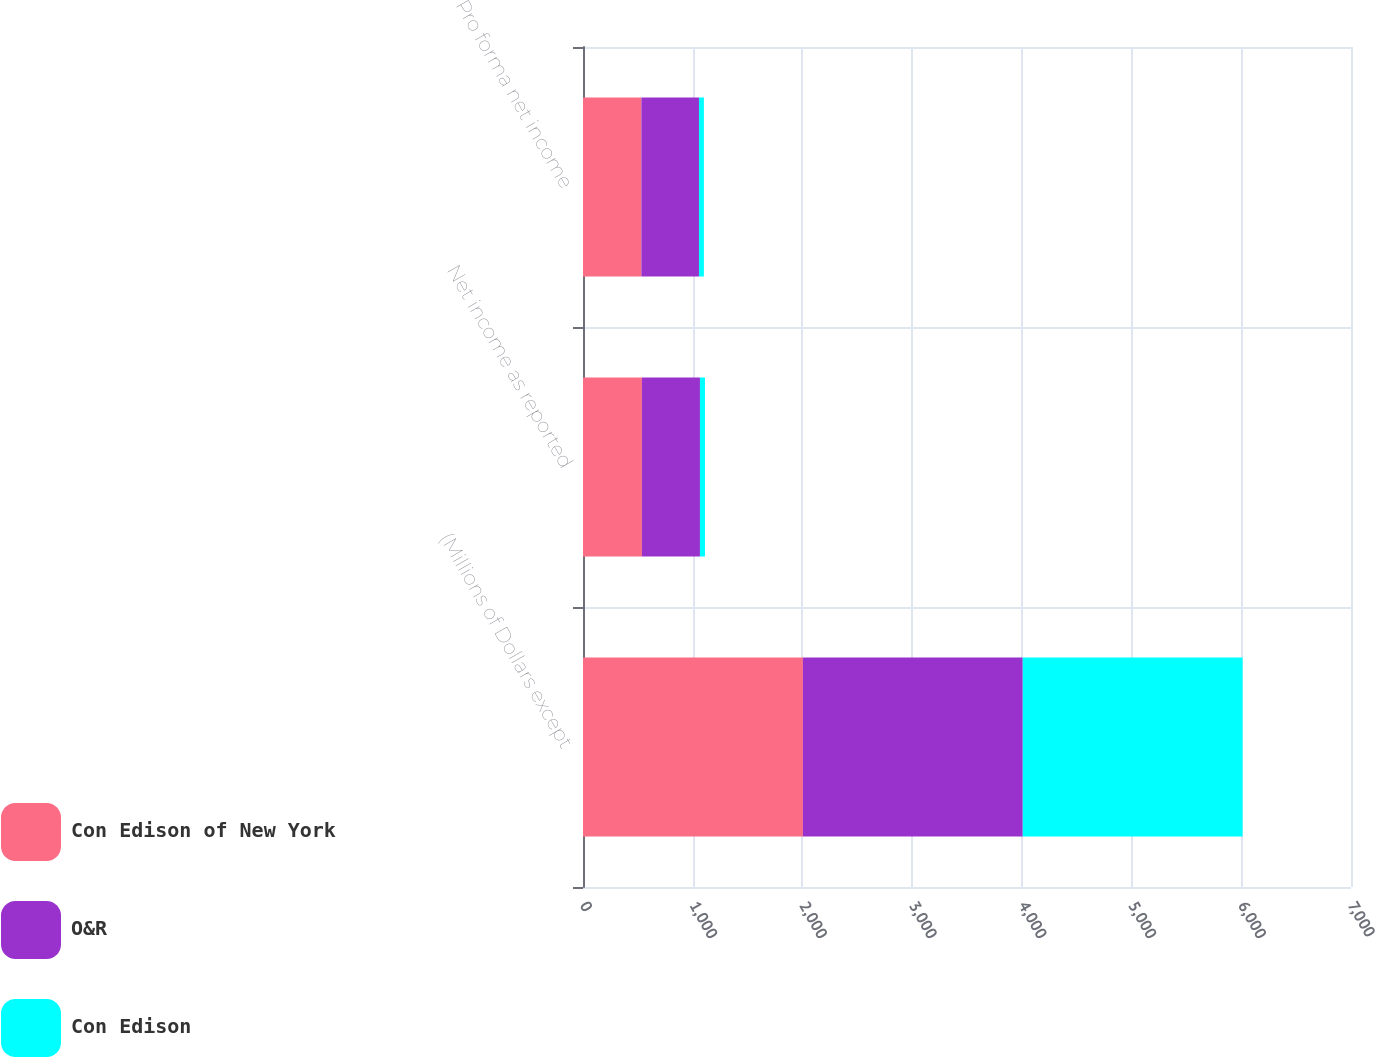Convert chart. <chart><loc_0><loc_0><loc_500><loc_500><stacked_bar_chart><ecel><fcel>(Millions of Dollars except<fcel>Net income as reported<fcel>Pro forma net income<nl><fcel>Con Edison of New York<fcel>2004<fcel>537<fcel>532<nl><fcel>O&R<fcel>2004<fcel>529<fcel>525<nl><fcel>Con Edison<fcel>2004<fcel>46<fcel>45<nl></chart> 